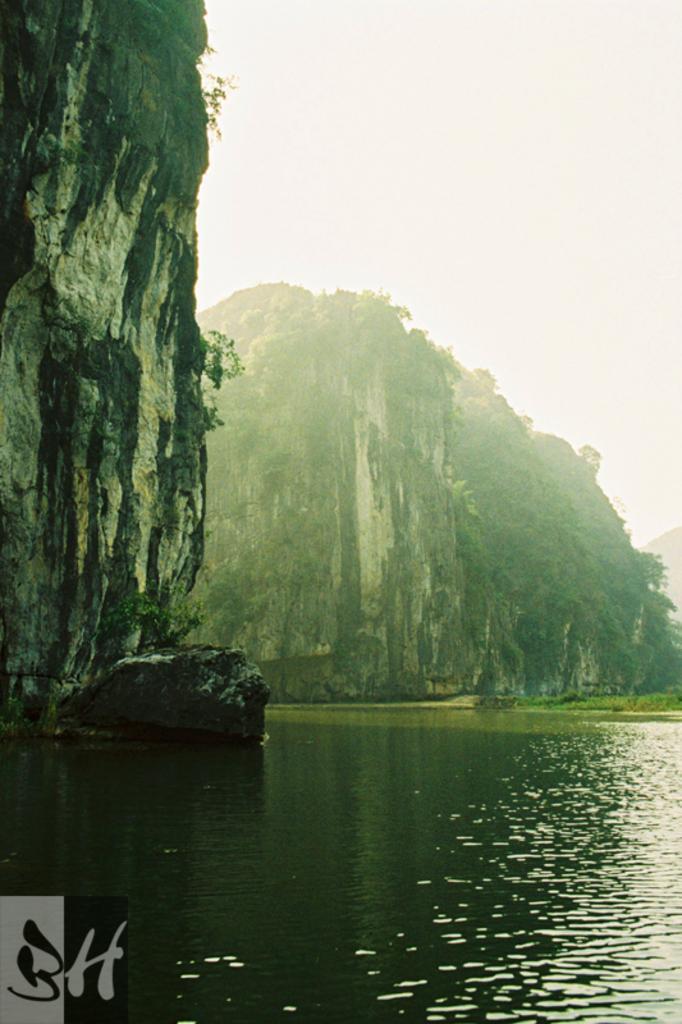In one or two sentences, can you explain what this image depicts? In this image I can see there is a river, mountains with trees and the sky is clear. 